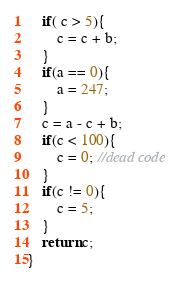Convert code to text. <code><loc_0><loc_0><loc_500><loc_500><_C_>	if( c > 5){
		c = c + b;
	}
	if(a == 0){
		a = 247;
	}
	c = a - c + b;
	if(c < 100){
		c = 0; //dead code
	}
	if(c != 0){
		c = 5;
	}
	return c;
}
</code> 